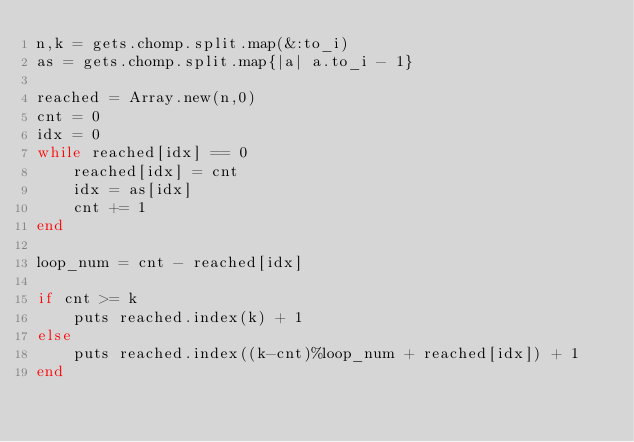Convert code to text. <code><loc_0><loc_0><loc_500><loc_500><_Ruby_>n,k = gets.chomp.split.map(&:to_i)
as = gets.chomp.split.map{|a| a.to_i - 1}

reached = Array.new(n,0)
cnt = 0
idx = 0
while reached[idx] == 0
	reached[idx] = cnt
	idx = as[idx]
	cnt += 1
end

loop_num = cnt - reached[idx]

if cnt >= k
	puts reached.index(k) + 1
else
	puts reached.index((k-cnt)%loop_num + reached[idx]) + 1
end</code> 